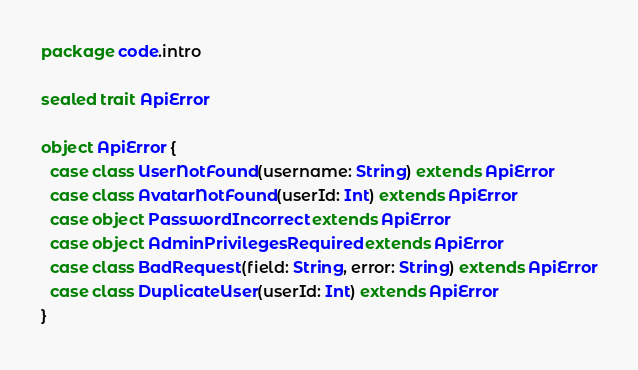<code> <loc_0><loc_0><loc_500><loc_500><_Scala_>package code.intro

sealed trait ApiError

object ApiError {
  case class UserNotFound(username: String) extends ApiError
  case class AvatarNotFound(userId: Int) extends ApiError
  case object PasswordIncorrect extends ApiError
  case object AdminPrivilegesRequired extends ApiError
  case class BadRequest(field: String, error: String) extends ApiError
  case class DuplicateUser(userId: Int) extends ApiError
}</code> 